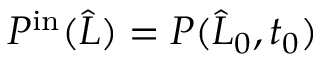Convert formula to latex. <formula><loc_0><loc_0><loc_500><loc_500>P ^ { i n } ( \widehat { L } ) = P ( \widehat { L } _ { 0 } , t _ { 0 } )</formula> 